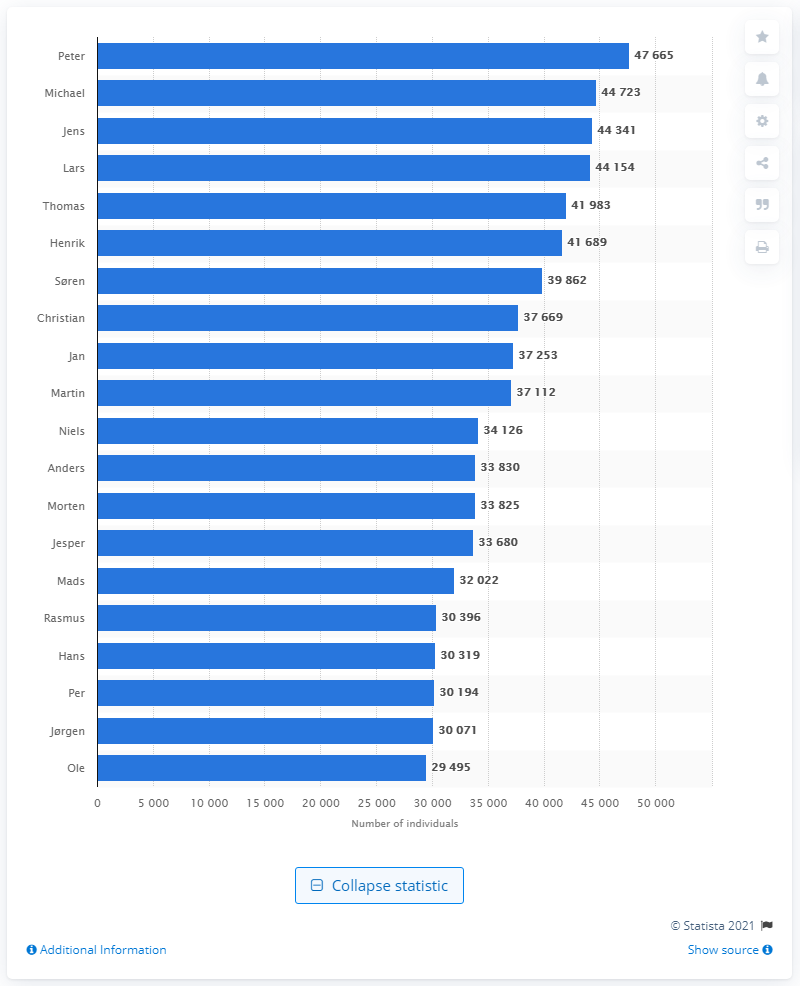List a handful of essential elements in this visual. In Denmark, there were 47,665 men who were named Peter. 